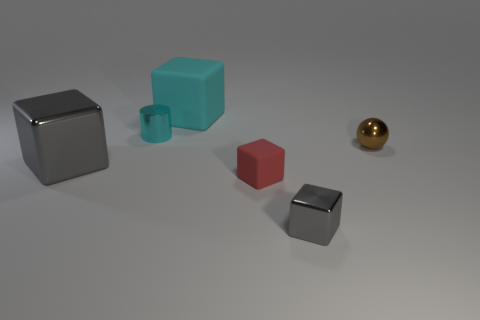Is there another tiny cube of the same color as the small matte cube?
Provide a short and direct response. No. Do the large cyan block and the small thing that is behind the tiny metal sphere have the same material?
Offer a terse response. No. How many small objects are either cyan metal things or cyan things?
Provide a succinct answer. 1. There is a object that is the same color as the small metallic cylinder; what is it made of?
Make the answer very short. Rubber. Is the number of big red shiny cubes less than the number of tiny red matte cubes?
Make the answer very short. Yes. Do the block to the left of the cyan rubber cube and the cyan matte block that is on the right side of the cyan cylinder have the same size?
Offer a terse response. Yes. What number of brown objects are either big matte spheres or tiny spheres?
Give a very brief answer. 1. What is the size of the other cube that is the same color as the big shiny block?
Provide a short and direct response. Small. Is the number of brown cylinders greater than the number of tiny gray objects?
Your answer should be compact. No. Do the large metallic thing and the small metallic ball have the same color?
Keep it short and to the point. No. 